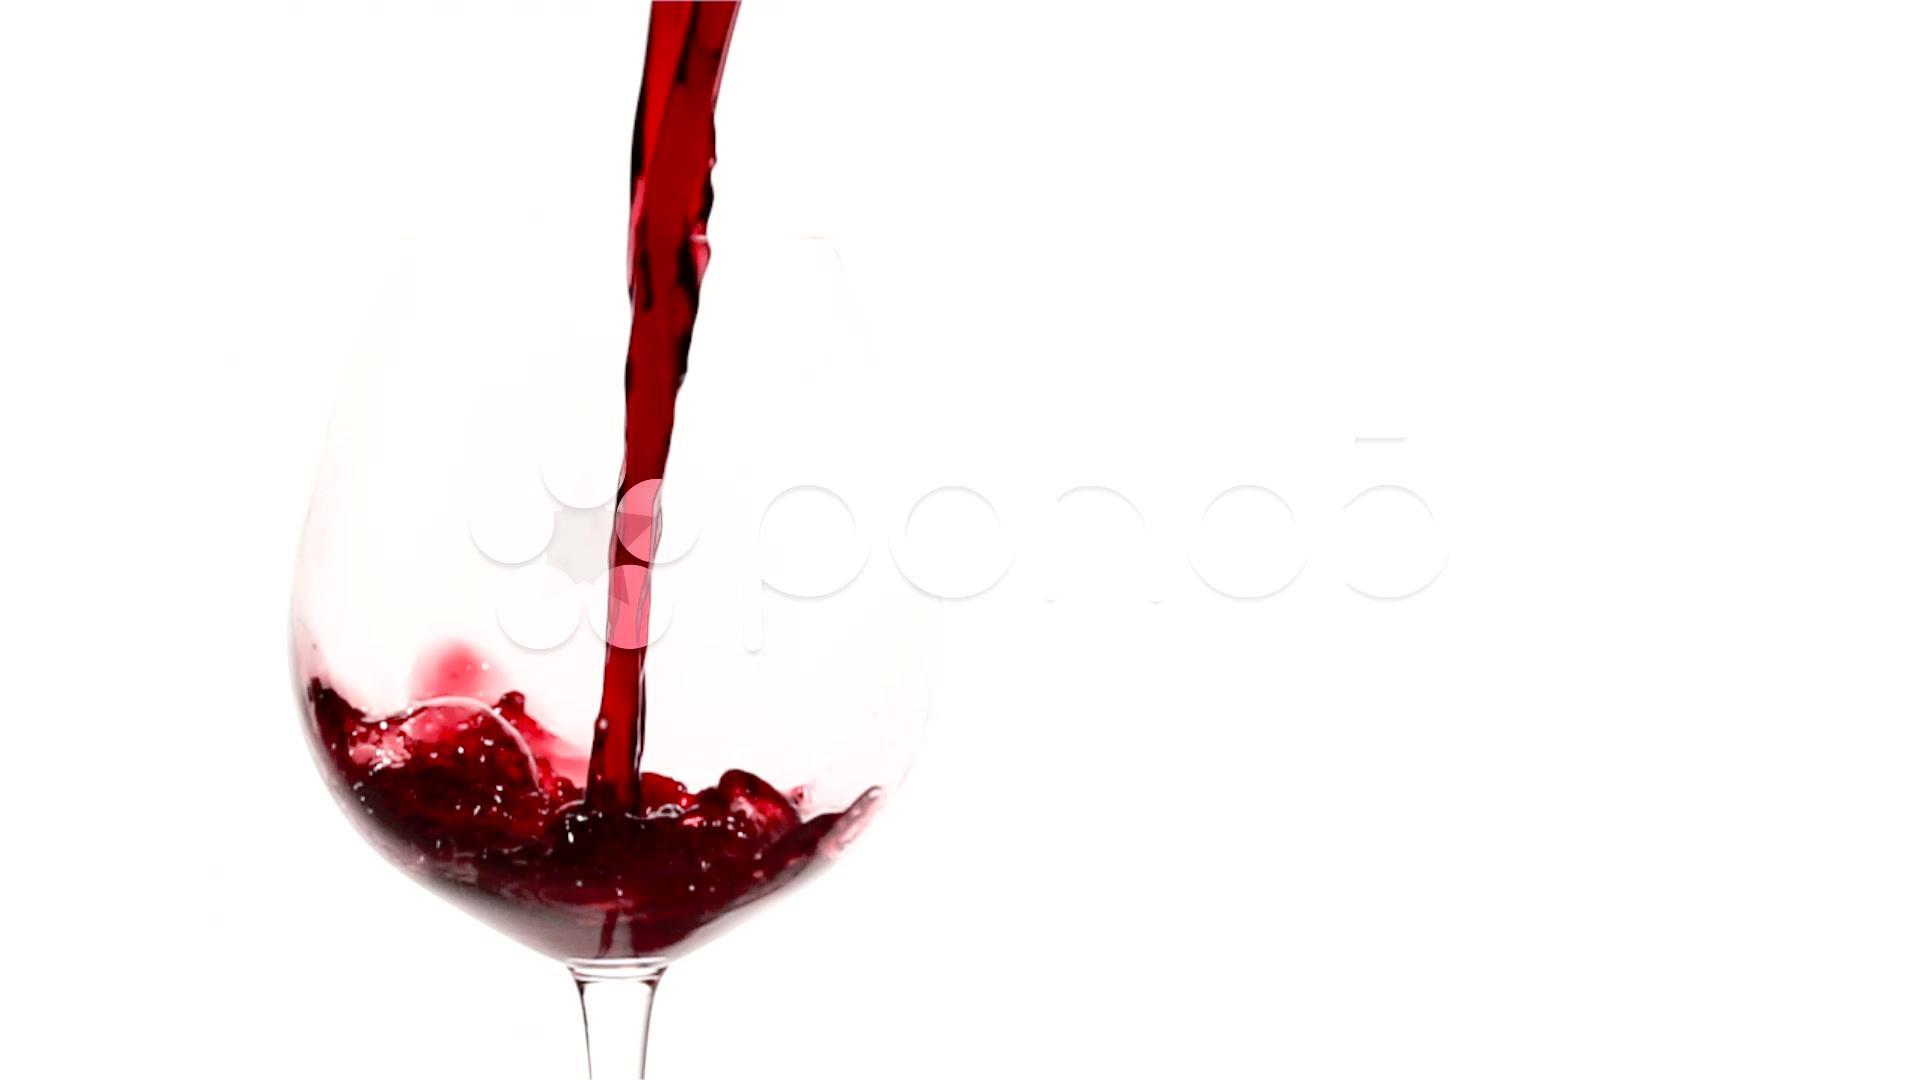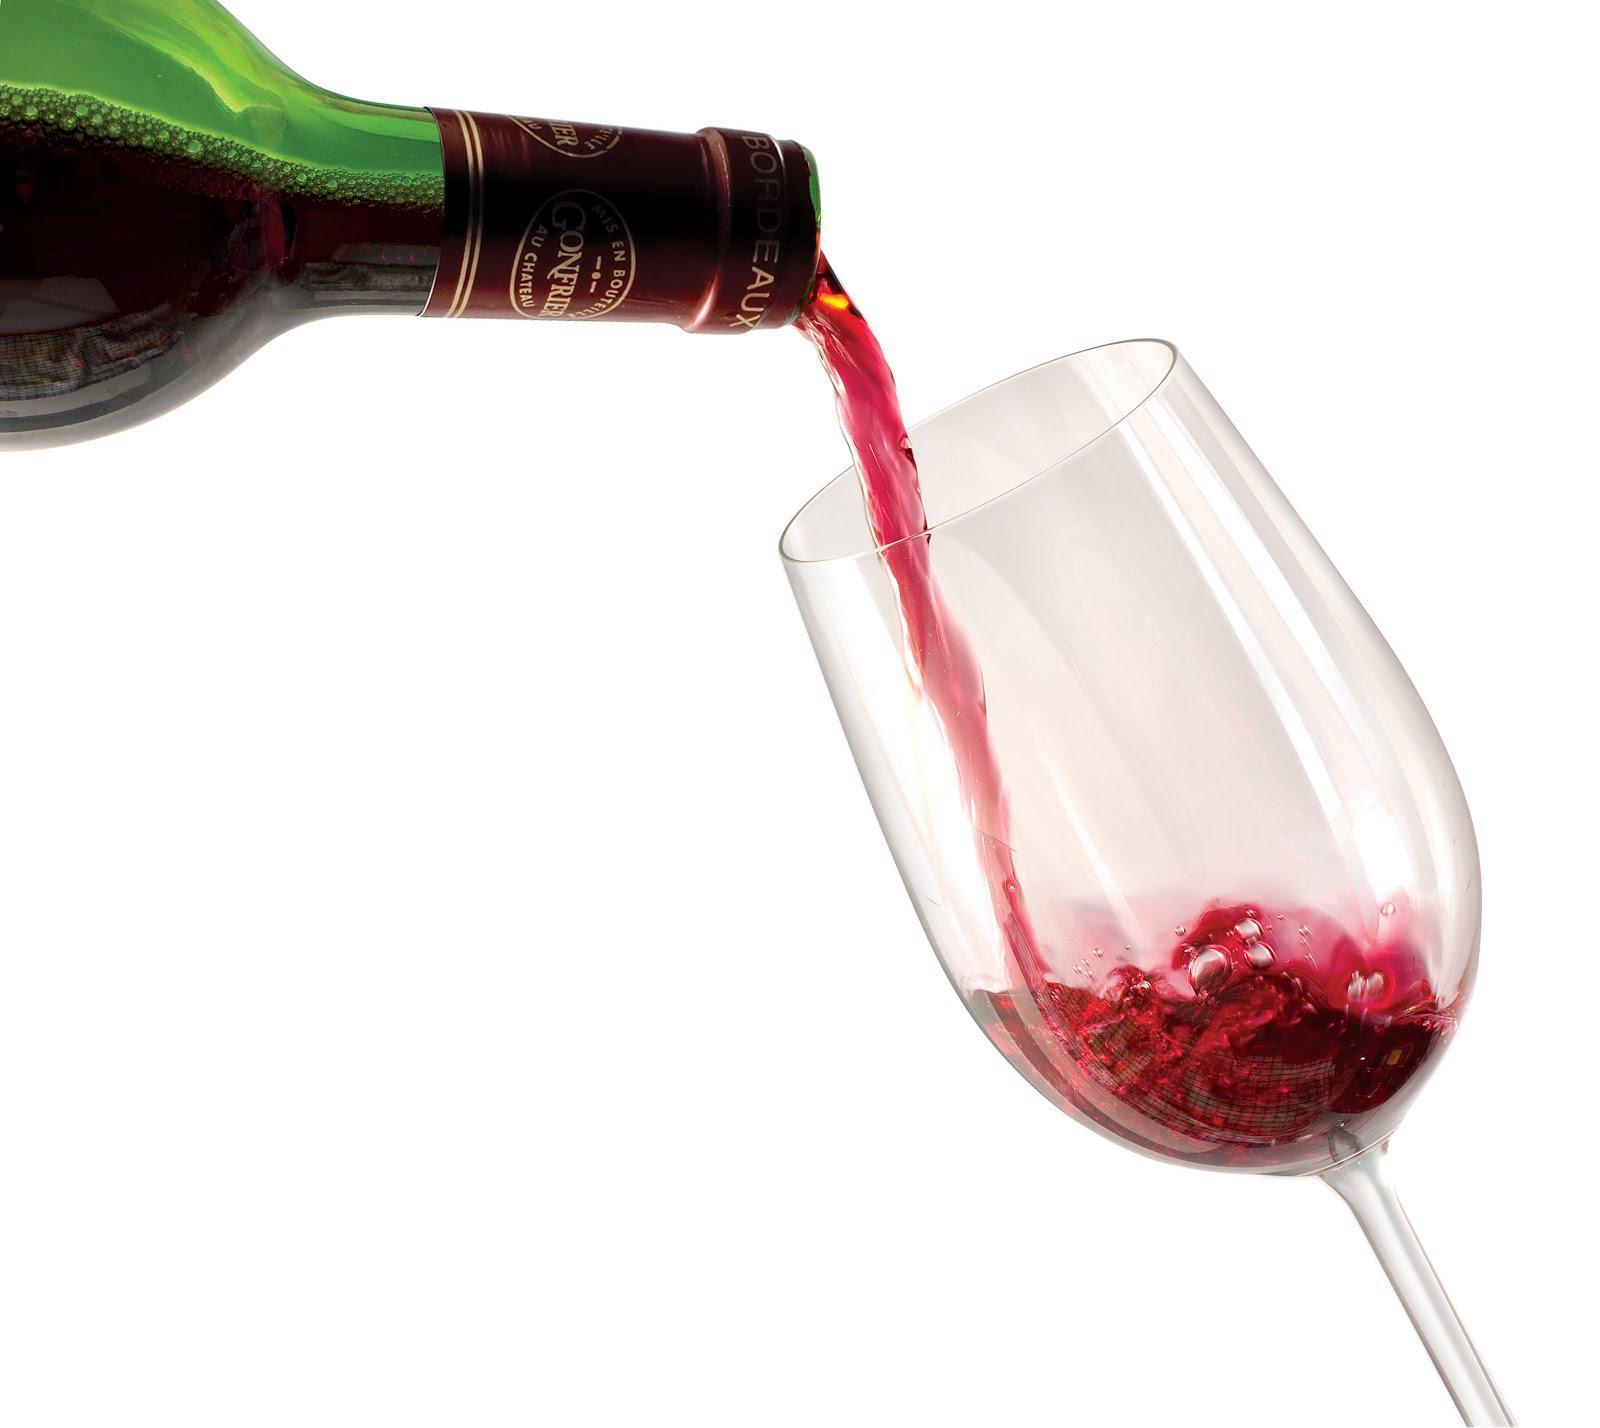The first image is the image on the left, the second image is the image on the right. For the images displayed, is the sentence "The neck of the bottle is near a glass." factually correct? Answer yes or no. Yes. 